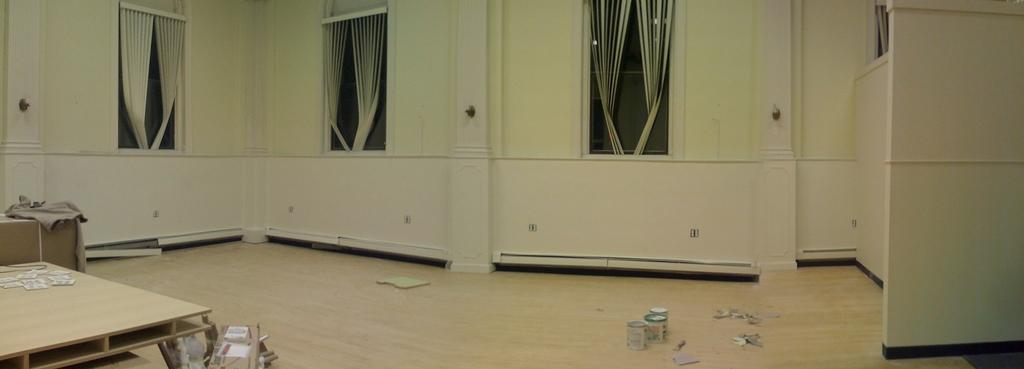What type of objects can be seen in the image? There are wooden objects in the image. What piece of furniture is present in the image? There is a table in the image. What is on the floor in the image? There are boxes on the floor in the image. What type of window treatment is visible in the image? There are curtains in the image. How many windows are visible in the image? There are windows in the image. What type of wall is present in the image? There is a wall in the image. Can you describe the possible setting of the image? The image may have been taken in a hall. What type of reward is hanging from the ceiling in the image? There is no reward hanging from the ceiling in the image; it only contains wooden objects, a table, boxes, curtains, windows, and a wall. What type of steel structure can be seen in the image? There is no steel structure present in the image. 